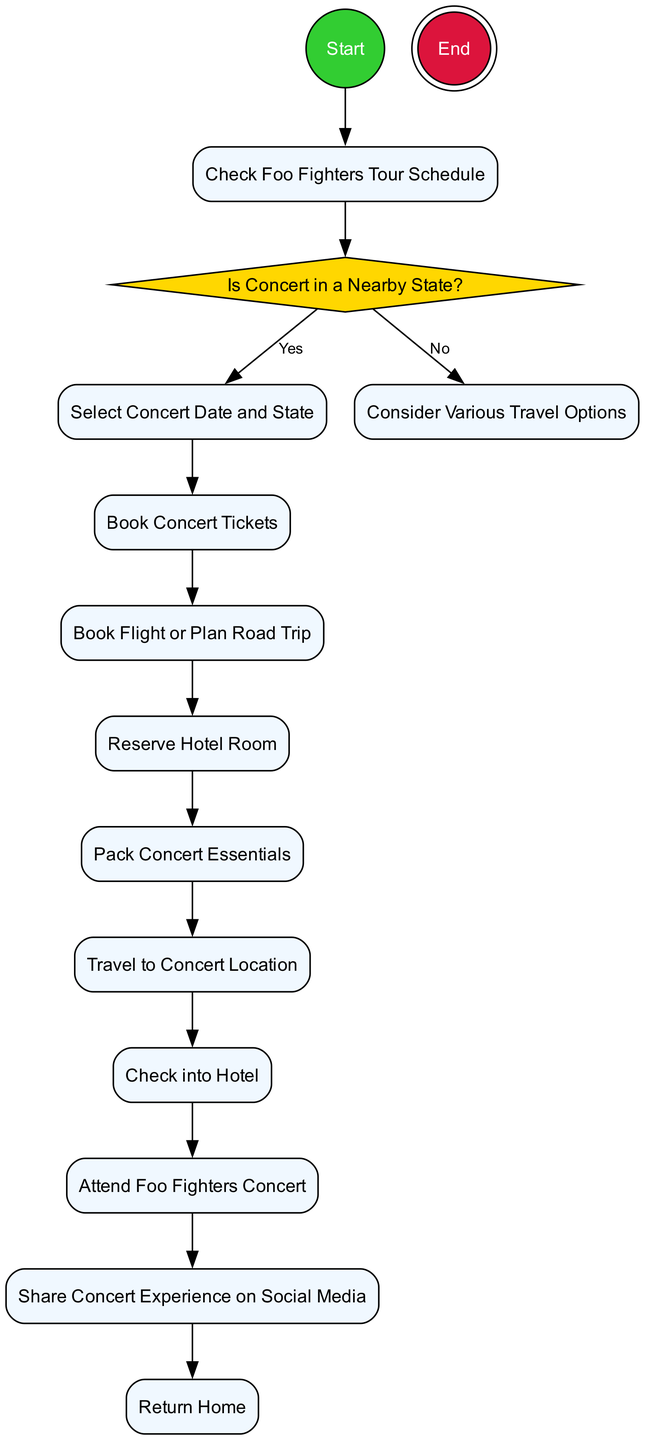What is the first action node in the diagram? The first action node listed in the diagram is "Check Foo Fighters Tour Schedule," which indicates the starting point for planning the trip.
Answer: Check Foo Fighters Tour Schedule How many action nodes are present in the diagram? Upon analyzing the diagram's structure, there are 9 action nodes, which detail the various steps involved in planning the trip.
Answer: 9 What is the final action before reaching the end node? The last action before reaching the end node is "Return Home," marking the conclusion of the trip planning process.
Answer: Return Home What decision is made in the diagram? The decision made in the diagram is "Is Concert in a Nearby State?" This decision determines the subsequent actions based on the concert location.
Answer: Is Concert in a Nearby State? If the concert is not in a nearby state, what is the next action? If it is determined that the concert is not in a nearby state, the next action taken is "Consider Various Travel Options" to explore how to reach the concert location.
Answer: Consider Various Travel Options How many branches does the decision node have? The decision node "Is Concert in a Nearby State?" has 2 branches: one for "Yes" and one for "No," allowing for two distinct paths based on the concert location.
Answer: 2 What happens after booking the concert tickets? After booking the concert tickets, the next action is "Book Flight or Plan Road Trip," which involves arranging transportation to the concert venue.
Answer: Book Flight or Plan Road Trip Which action follows sharing the concert experience on social media? The action that follows sharing the concert experience on social media is "Return Home," indicating that after sharing, the trip concludes with returning home.
Answer: Return Home What type of diagram is this? This is an activity diagram, which represents the workflow of tasks involved in planning a trip to a concert, showcasing the sequence of actions and decisions.
Answer: Activity Diagram 